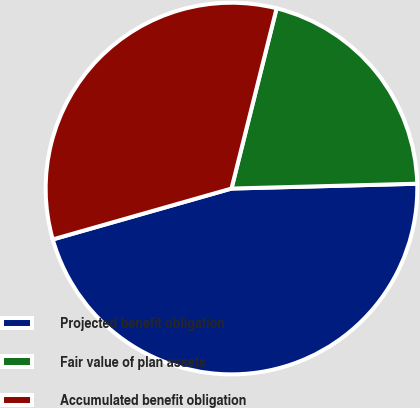<chart> <loc_0><loc_0><loc_500><loc_500><pie_chart><fcel>Projected benefit obligation<fcel>Fair value of plan assets<fcel>Accumulated benefit obligation<nl><fcel>46.0%<fcel>20.68%<fcel>33.32%<nl></chart> 